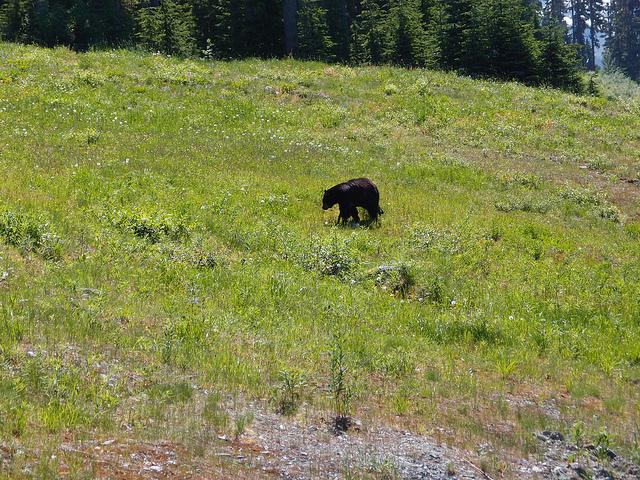Can you see through the forest?
Concise answer only. Yes. What color is the bear?
Short answer required. Black. Is there a forest?
Short answer required. Yes. 